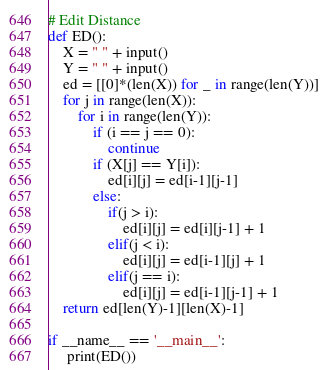Convert code to text. <code><loc_0><loc_0><loc_500><loc_500><_Python_># Edit Distance
def ED():
    X = " " + input()
    Y = " " + input()
    ed = [[0]*(len(X)) for _ in range(len(Y))]
    for j in range(len(X)):
        for i in range(len(Y)):
            if (i == j == 0):
                continue
            if (X[j] == Y[i]):
                ed[i][j] = ed[i-1][j-1]
            else:
                if(j > i):
                    ed[i][j] = ed[i][j-1] + 1
                elif(j < i):
                    ed[i][j] = ed[i-1][j] + 1
                elif(j == i):
                    ed[i][j] = ed[i-1][j-1] + 1
    return ed[len(Y)-1][len(X)-1]

if __name__ == '__main__':
     print(ED())</code> 